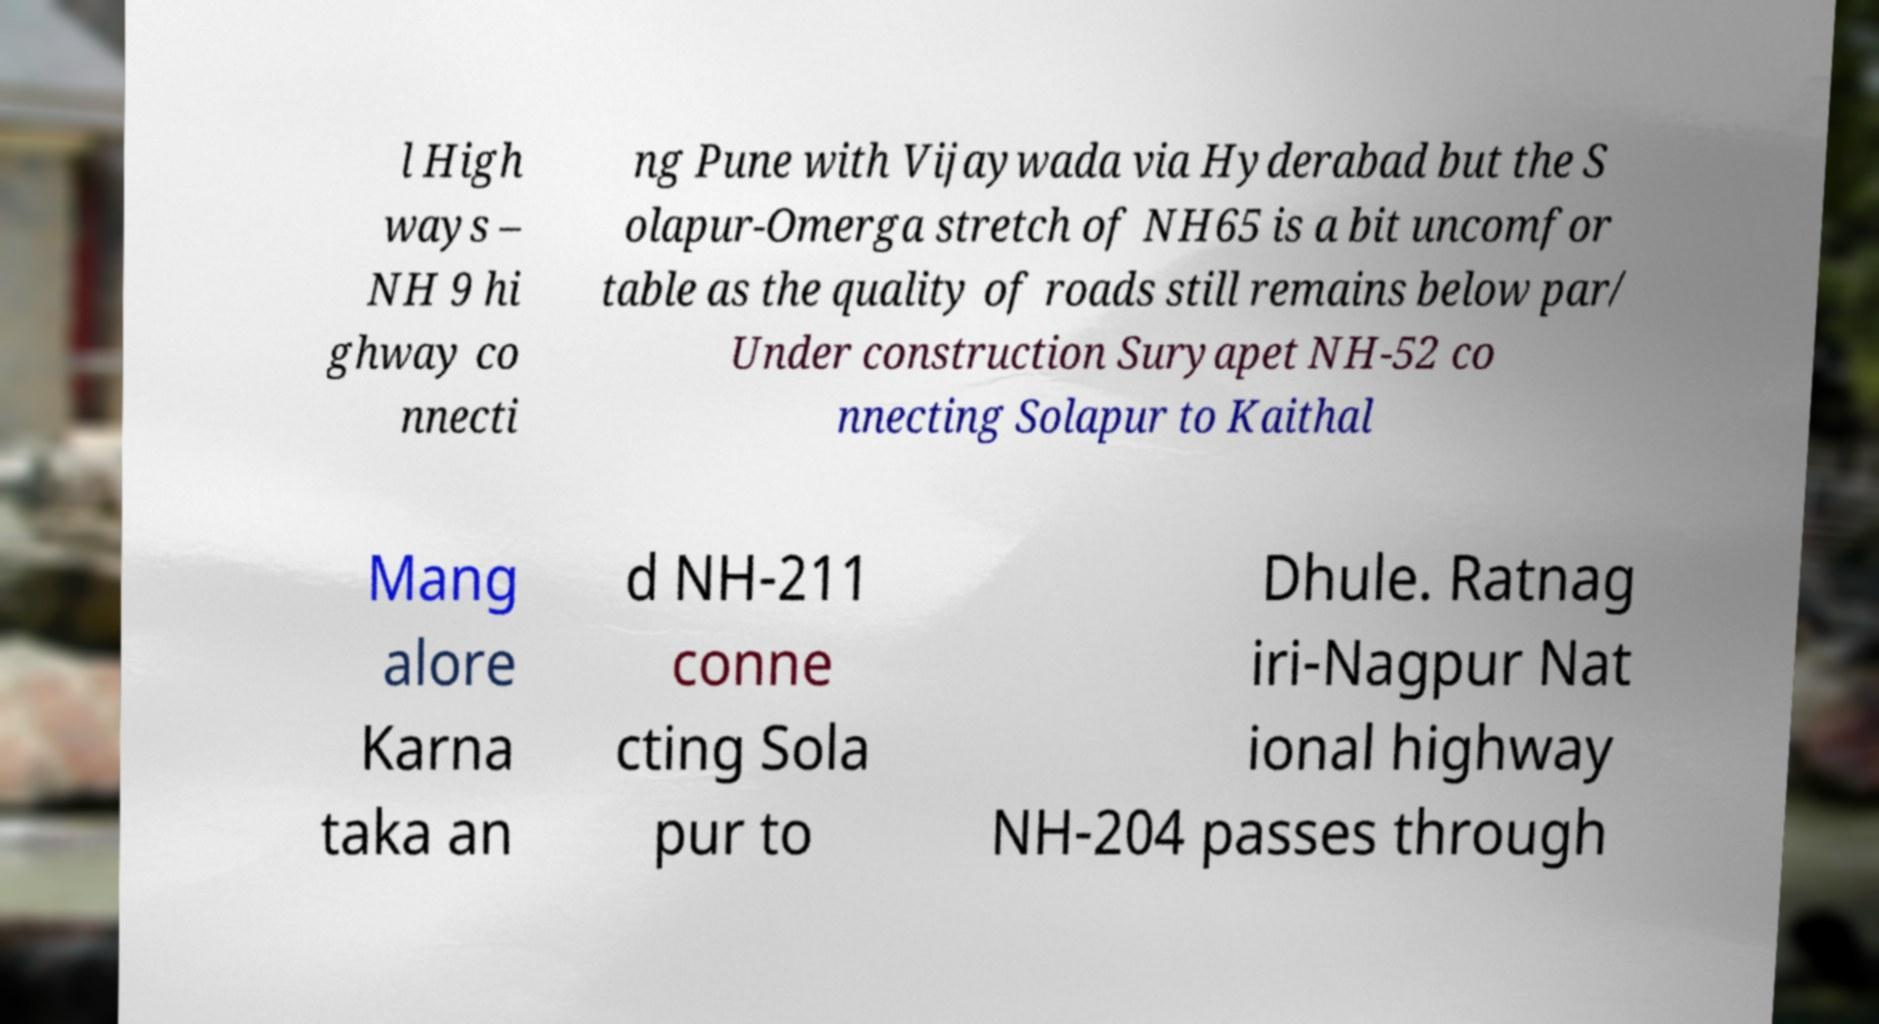For documentation purposes, I need the text within this image transcribed. Could you provide that? l High ways – NH 9 hi ghway co nnecti ng Pune with Vijaywada via Hyderabad but the S olapur-Omerga stretch of NH65 is a bit uncomfor table as the quality of roads still remains below par/ Under construction Suryapet NH-52 co nnecting Solapur to Kaithal Mang alore Karna taka an d NH-211 conne cting Sola pur to Dhule. Ratnag iri-Nagpur Nat ional highway NH-204 passes through 